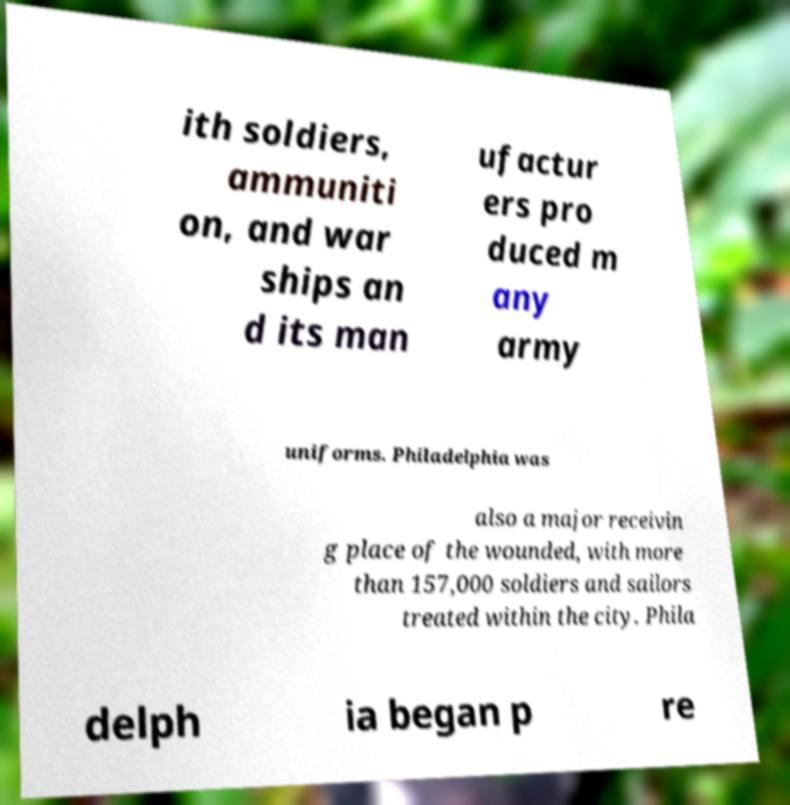Can you read and provide the text displayed in the image?This photo seems to have some interesting text. Can you extract and type it out for me? ith soldiers, ammuniti on, and war ships an d its man ufactur ers pro duced m any army uniforms. Philadelphia was also a major receivin g place of the wounded, with more than 157,000 soldiers and sailors treated within the city. Phila delph ia began p re 